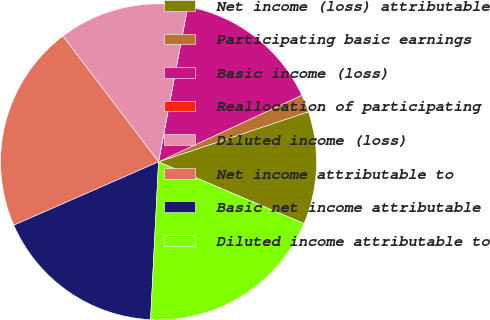<chart> <loc_0><loc_0><loc_500><loc_500><pie_chart><fcel>Net income (loss) attributable<fcel>Participating basic earnings<fcel>Basic income (loss)<fcel>Reallocation of participating<fcel>Diluted income (loss)<fcel>Net income attributable to<fcel>Basic net income attributable<fcel>Diluted income attributable to<nl><fcel>11.52%<fcel>1.8%<fcel>15.11%<fcel>0.0%<fcel>13.31%<fcel>21.22%<fcel>17.63%<fcel>19.42%<nl></chart> 